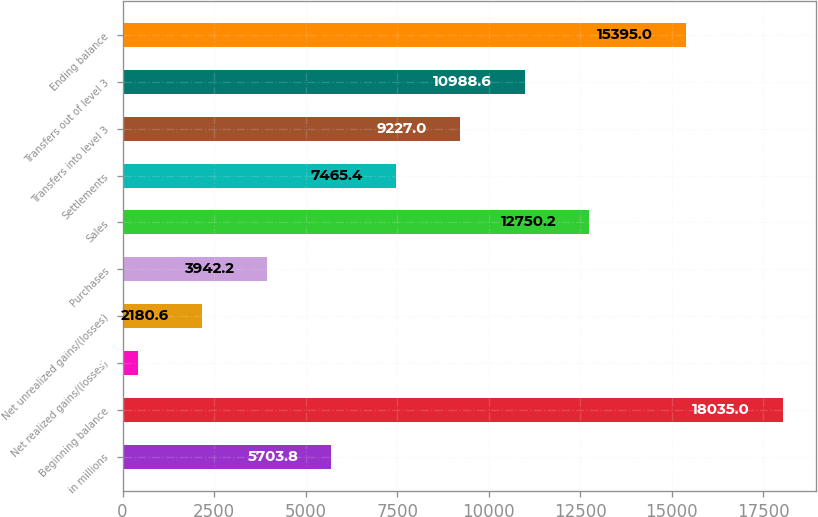Convert chart to OTSL. <chart><loc_0><loc_0><loc_500><loc_500><bar_chart><fcel>in millions<fcel>Beginning balance<fcel>Net realized gains/(losses)<fcel>Net unrealized gains/(losses)<fcel>Purchases<fcel>Sales<fcel>Settlements<fcel>Transfers into level 3<fcel>Transfers out of level 3<fcel>Ending balance<nl><fcel>5703.8<fcel>18035<fcel>419<fcel>2180.6<fcel>3942.2<fcel>12750.2<fcel>7465.4<fcel>9227<fcel>10988.6<fcel>15395<nl></chart> 